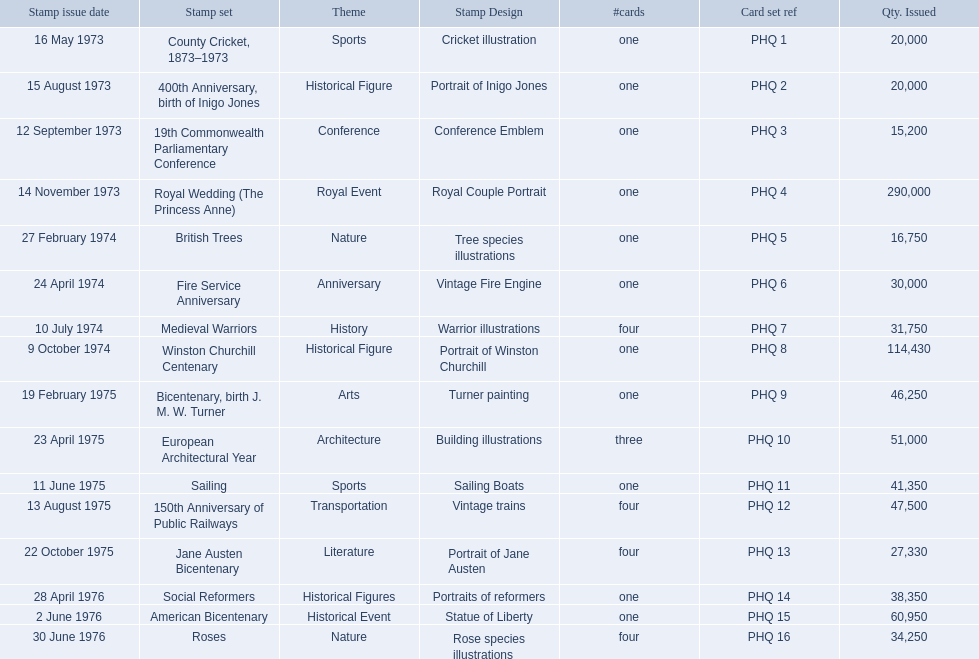Which stamp sets were issued? County Cricket, 1873–1973, 400th Anniversary, birth of Inigo Jones, 19th Commonwealth Parliamentary Conference, Royal Wedding (The Princess Anne), British Trees, Fire Service Anniversary, Medieval Warriors, Winston Churchill Centenary, Bicentenary, birth J. M. W. Turner, European Architectural Year, Sailing, 150th Anniversary of Public Railways, Jane Austen Bicentenary, Social Reformers, American Bicentenary, Roses. Of those stamp sets, which had more that 200,000 issued? Royal Wedding (The Princess Anne). 